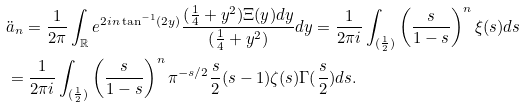<formula> <loc_0><loc_0><loc_500><loc_500>& \ddot { a } _ { n } = \frac { 1 } { 2 \pi } \int _ { \mathbb { R } } e ^ { 2 i n \tan ^ { - 1 } ( 2 y ) } \frac { ( \frac { 1 } { 4 } + y ^ { 2 } ) \Xi ( y ) d y } { ( \frac { 1 } { 4 } + y ^ { 2 } ) } d y = \frac { 1 } { 2 \pi i } \int _ { ( \frac { 1 } { 2 } ) } \left ( \frac { s } { 1 - s } \right ) ^ { n } \xi ( s ) d s \\ & = \frac { 1 } { 2 \pi i } \int _ { ( \frac { 1 } { 2 } ) } \left ( \frac { s } { 1 - s } \right ) ^ { n } \pi ^ { - s / 2 } \frac { s } { 2 } ( s - 1 ) \zeta ( s ) \Gamma ( \frac { s } { 2 } ) d s .</formula> 